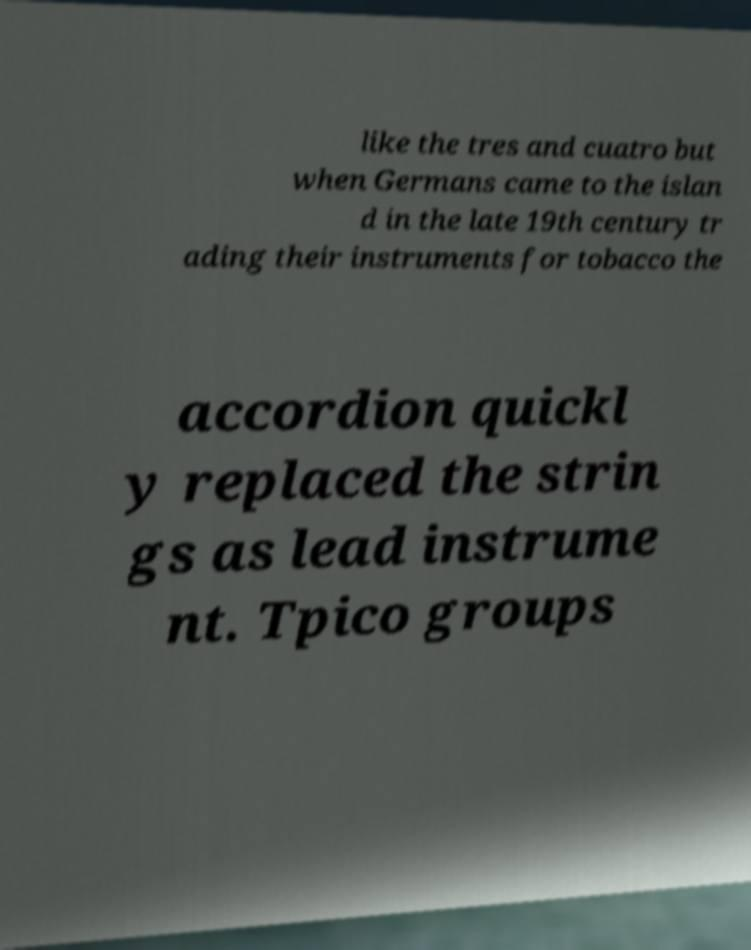For documentation purposes, I need the text within this image transcribed. Could you provide that? like the tres and cuatro but when Germans came to the islan d in the late 19th century tr ading their instruments for tobacco the accordion quickl y replaced the strin gs as lead instrume nt. Tpico groups 